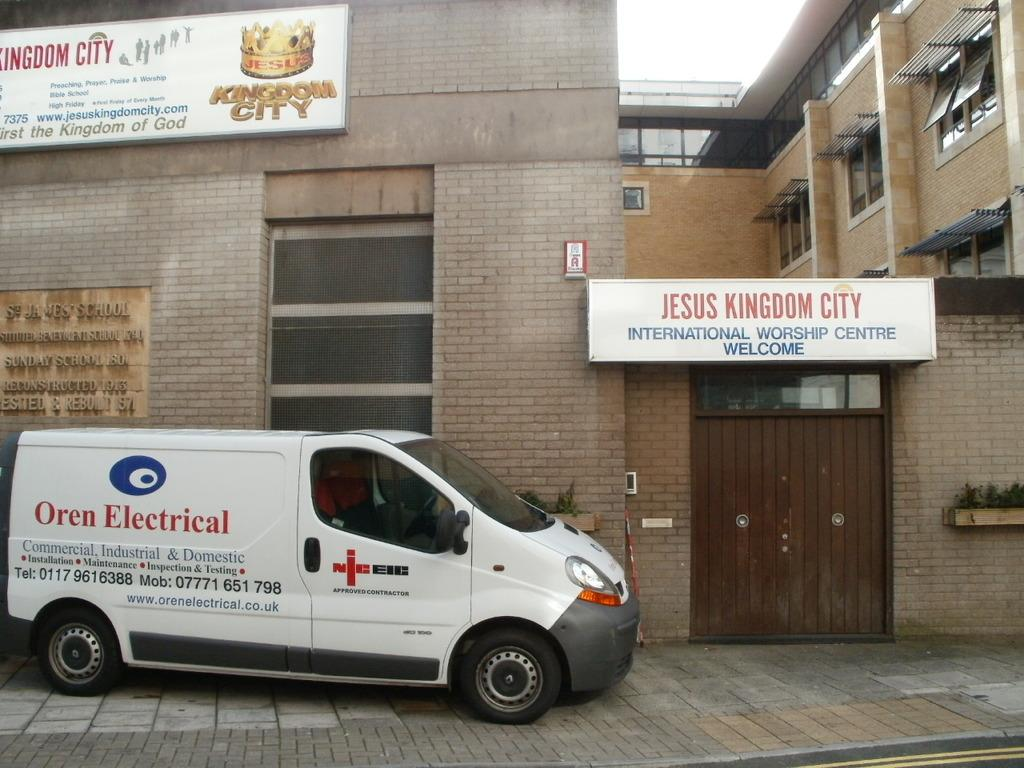<image>
Provide a brief description of the given image. An Oren Electrical van is parked outside Jesus Kingdom City. 